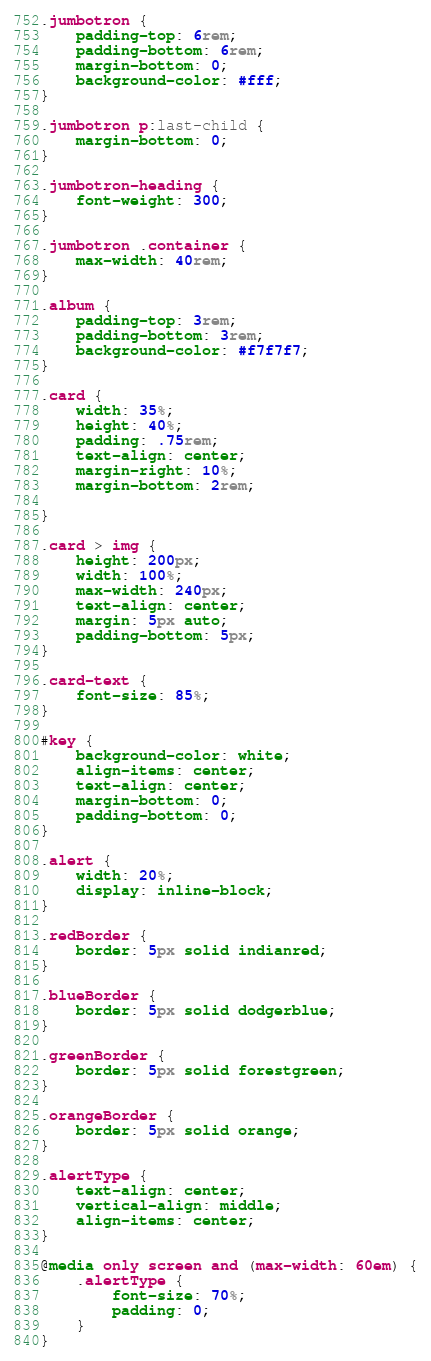<code> <loc_0><loc_0><loc_500><loc_500><_CSS_>.jumbotron {
    padding-top: 6rem;
    padding-bottom: 6rem;
    margin-bottom: 0;
    background-color: #fff;
}

.jumbotron p:last-child {
    margin-bottom: 0;
}

.jumbotron-heading {
    font-weight: 300;
}

.jumbotron .container {
    max-width: 40rem;
}

.album {
    padding-top: 3rem;
    padding-bottom: 3rem;
    background-color: #f7f7f7;
}

.card {
    width: 35%;
    height: 40%;
    padding: .75rem;
    text-align: center;
    margin-right: 10%;
    margin-bottom: 2rem;

}

.card > img {
    height: 200px;
    width: 100%;
    max-width: 240px;
    text-align: center;
    margin: 5px auto;
    padding-bottom: 5px;
}

.card-text {
    font-size: 85%;
}

#key {
    background-color: white;
    align-items: center;
    text-align: center;
    margin-bottom: 0;
    padding-bottom: 0;
}

.alert {
    width: 20%;
    display: inline-block;
}

.redBorder {
    border: 5px solid indianred;
}

.blueBorder {
    border: 5px solid dodgerblue;
}

.greenBorder {
    border: 5px solid forestgreen;
}

.orangeBorder {
    border: 5px solid orange;
}

.alertType {
    text-align: center;
    vertical-align: middle;
    align-items: center;
}

@media only screen and (max-width: 60em) {
    .alertType {
        font-size: 70%;
        padding: 0;
    }
}
</code> 